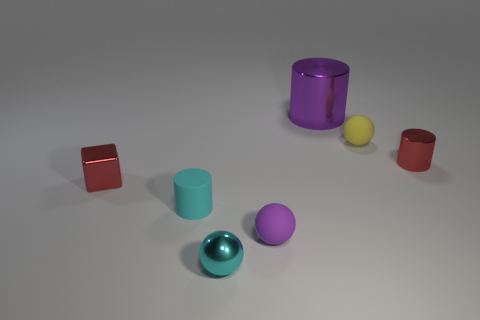The yellow object has what shape?
Give a very brief answer. Sphere. The small sphere that is made of the same material as the red block is what color?
Ensure brevity in your answer.  Cyan. Is the number of purple objects greater than the number of purple metallic cylinders?
Provide a short and direct response. Yes. Are the tiny red cylinder and the large cylinder made of the same material?
Give a very brief answer. Yes. What is the shape of the tiny cyan thing that is made of the same material as the small yellow thing?
Your answer should be very brief. Cylinder. Are there fewer small matte spheres than large purple things?
Keep it short and to the point. No. There is a thing that is in front of the yellow sphere and right of the large metal cylinder; what material is it?
Your answer should be very brief. Metal. What size is the metal object that is in front of the cylinder in front of the red object that is left of the cyan metal ball?
Your answer should be very brief. Small. Does the tiny purple object have the same shape as the red thing right of the big metallic thing?
Provide a succinct answer. No. What number of small spheres are both behind the shiny ball and on the left side of the large purple object?
Give a very brief answer. 1. 